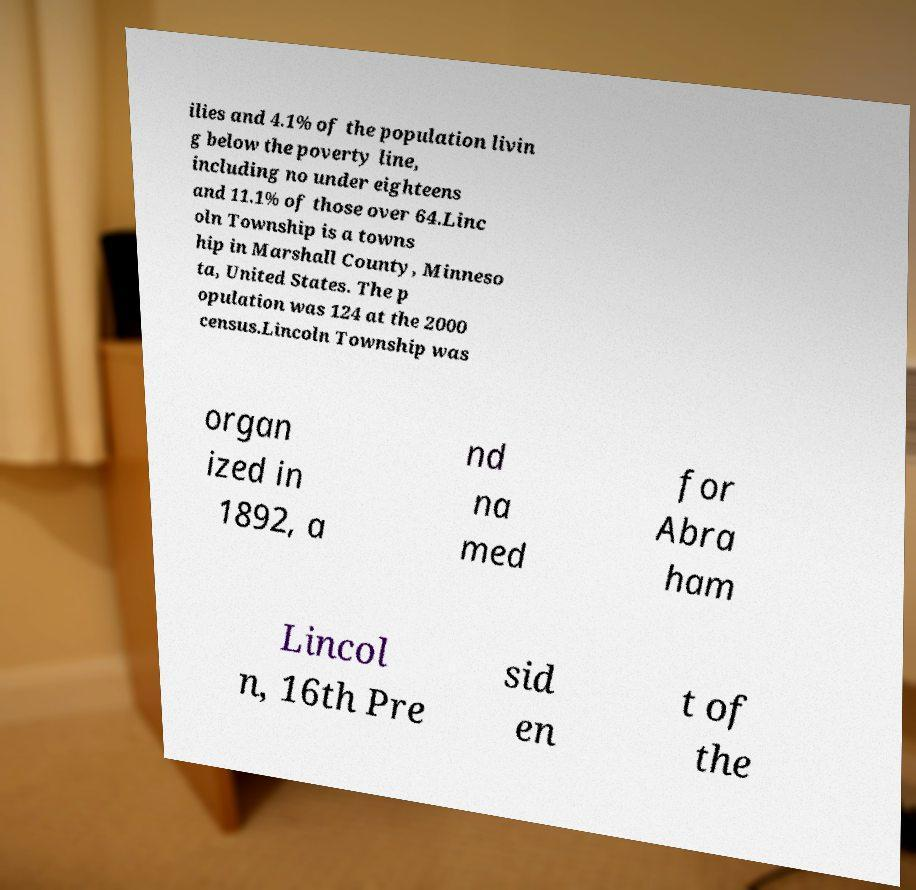What messages or text are displayed in this image? I need them in a readable, typed format. ilies and 4.1% of the population livin g below the poverty line, including no under eighteens and 11.1% of those over 64.Linc oln Township is a towns hip in Marshall County, Minneso ta, United States. The p opulation was 124 at the 2000 census.Lincoln Township was organ ized in 1892, a nd na med for Abra ham Lincol n, 16th Pre sid en t of the 